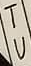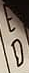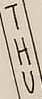Read the text from these images in sequence, separated by a semicolon. TU; ED; THU 